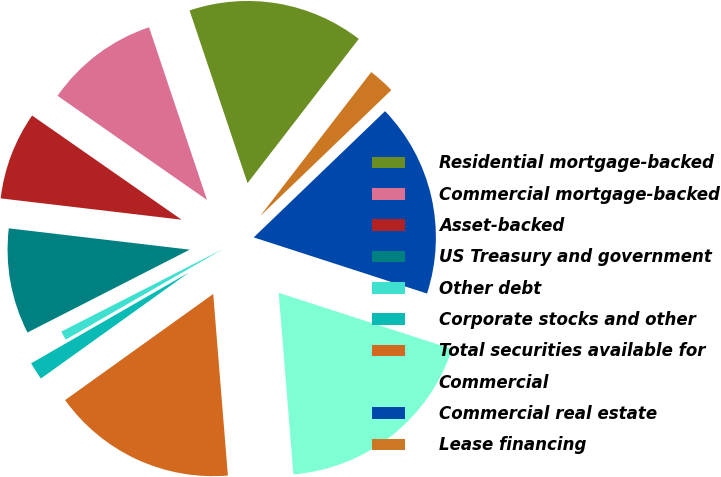Convert chart to OTSL. <chart><loc_0><loc_0><loc_500><loc_500><pie_chart><fcel>Residential mortgage-backed<fcel>Commercial mortgage-backed<fcel>Asset-backed<fcel>US Treasury and government<fcel>Other debt<fcel>Corporate stocks and other<fcel>Total securities available for<fcel>Commercial<fcel>Commercial real estate<fcel>Lease financing<nl><fcel>15.61%<fcel>10.16%<fcel>7.82%<fcel>9.38%<fcel>0.8%<fcel>1.58%<fcel>16.39%<fcel>18.73%<fcel>17.17%<fcel>2.36%<nl></chart> 